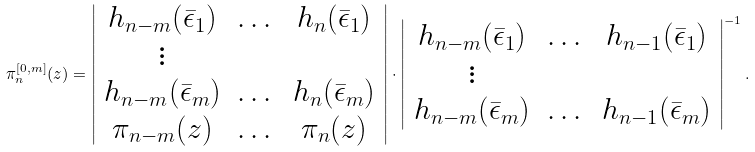Convert formula to latex. <formula><loc_0><loc_0><loc_500><loc_500>\pi _ { n } ^ { [ 0 , m ] } ( z ) = \left | \begin{array} { c c c } h _ { n - m } ( \bar { \epsilon } _ { 1 } ) & \dots & h _ { n } ( \bar { \epsilon } _ { 1 } ) \\ \vdots & & \\ h _ { n - m } ( \bar { \epsilon } _ { m } ) & \dots & h _ { n } ( \bar { \epsilon } _ { m } ) \\ \pi _ { n - m } ( z ) & \dots & \pi _ { n } ( z ) \end{array} \right | \cdot \left | \begin{array} { c c c } h _ { n - m } ( \bar { \epsilon } _ { 1 } ) & \dots & h _ { n - 1 } ( \bar { \epsilon } _ { 1 } ) \\ \vdots & & \\ h _ { n - m } ( \bar { \epsilon } _ { m } ) & \dots & h _ { n - 1 } ( \bar { \epsilon } _ { m } ) \end{array} \right | ^ { - 1 } .</formula> 